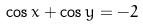<formula> <loc_0><loc_0><loc_500><loc_500>\cos x + \cos y = - 2</formula> 